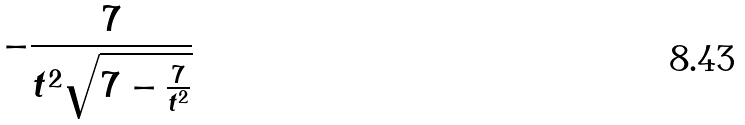<formula> <loc_0><loc_0><loc_500><loc_500>- \frac { 7 } { t ^ { 2 } \sqrt { 7 - \frac { 7 } { t ^ { 2 } } } }</formula> 